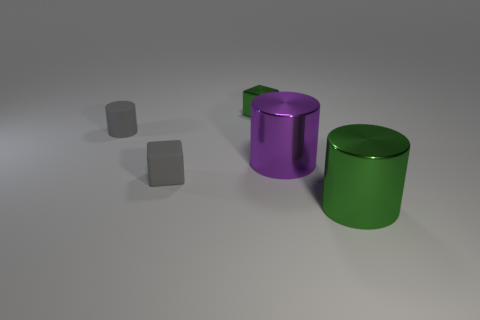The big shiny cylinder behind the big shiny cylinder in front of the small gray matte block is what color?
Your response must be concise. Purple. There is a gray thing right of the small gray cylinder; what is it made of?
Your answer should be compact. Rubber. Are there fewer large green objects than large purple metal cubes?
Make the answer very short. No. Is the shape of the purple metallic object the same as the green metal thing in front of the matte cylinder?
Keep it short and to the point. Yes. The thing that is in front of the large purple object and to the right of the tiny green cube has what shape?
Ensure brevity in your answer.  Cylinder. Are there the same number of gray cylinders that are in front of the large purple object and small green metal cubes that are on the right side of the tiny green metal object?
Make the answer very short. Yes. There is a green thing in front of the purple cylinder; is its shape the same as the purple object?
Keep it short and to the point. Yes. What number of yellow things are either large shiny objects or metallic things?
Provide a succinct answer. 0. There is another big object that is the same shape as the big purple metallic thing; what is its material?
Keep it short and to the point. Metal. What is the shape of the green thing that is right of the small green shiny thing?
Ensure brevity in your answer.  Cylinder. 